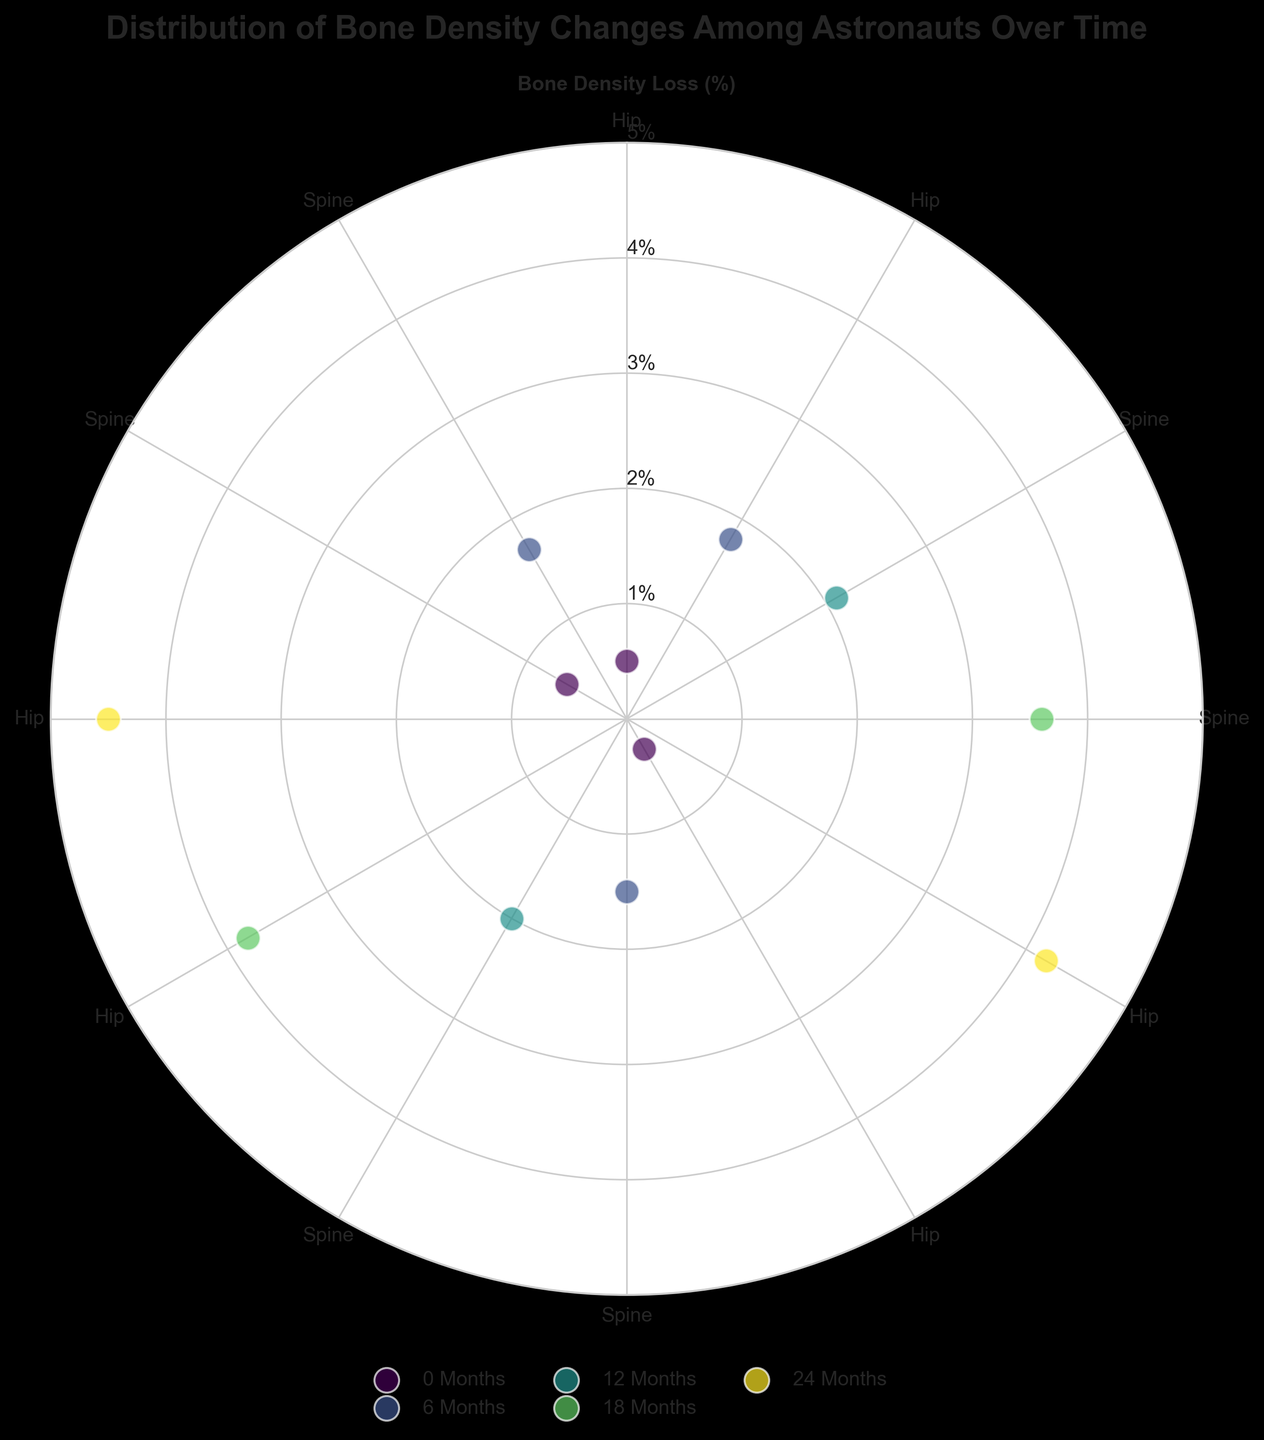What is the title of the figure? The title is typically found at the top of the figure in a prominent font size. The title summarizes the data being presented in the figure.
Answer: Distribution of Bone Density Changes Among Astronauts Over Time How many different time periods are represented in the figure? Each time period is represented by a unique color in the scatter plot, as indicated in the legend. Counting these distinct colors in the legend will give the number of different time periods.
Answer: 5 For which body part do the scatter points at 180 degrees represent data? The angles correspond to specific body parts as indicated by the thetagrids. The data points at 180 degrees need to be checked against the thetagrids labels to identify the corresponding body part.
Answer: Hip What time period shows the largest bone density loss in the spine? To find the largest bone density loss, look at the scatter points associated with the spine and identify which time period has the highest value on the radial axis.
Answer: 24 Months Between 0 and 12 months, which body part shows a higher rate of bone density loss, the hip or the spine? For each time period (0 and 12 months), compare the values of 'Percentage Bone Density Change' for the hip and spine to determine which has the greater loss.
Answer: Hip What is the difference in bone density loss between the hip and spine at 18 months? Find the scatter points for the hip and spine at 18 months, note their values, and then subtract the smaller value from the larger.
Answer: 0.2% Is the bone density loss generally more severe in the hip or the spine over the observed periods? By comparing the scatter points' values (which reflect bone density loss) at similar angles for hip and spine across all time periods, we can determine which body part generally shows greater loss.
Answer: Spine What is the bone density loss percentage for David Brown at 0 months in the figure? Locate the angle for 150 degrees and check the scatter point at 0 months. Note its radial distance which indicates bone density loss percentage.
Answer: 0.3% How does the rate of bone density loss change for the hip over each time period? Look at the scatter points for the hip at each time period (0, 6, 12, 18, 24 months), and observe how the values change with each period.
Answer: Increases over time Which astronaut shows the most significant bone density loss and at what time period? Identify the scatter point with the highest bone density loss value and check the legend to find the time period and the label to find the astronaut.
Answer: James Moore at 24 Months 